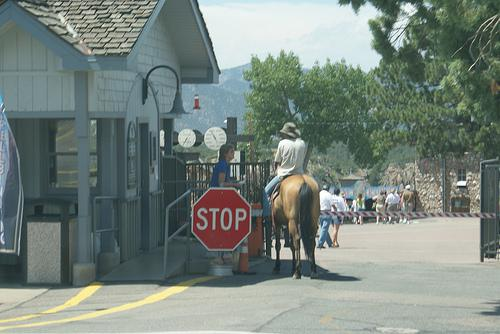Question: who is on a horse?
Choices:
A. A woman.
B. A man.
C. A child.
D. A person.
Answer with the letter. Answer: D Question: where are yellow lines?
Choices:
A. On the ground.
B. On the car.
C. On the bench.
D. On the window.
Answer with the letter. Answer: A Question: what is gray?
Choices:
A. Sky.
B. Ground.
C. Cat.
D. Man's hair.
Answer with the letter. Answer: B Question: what is brown?
Choices:
A. Horse.
B. Deer.
C. Dog.
D. Rabbit.
Answer with the letter. Answer: A Question: what is blue?
Choices:
A. Flowers.
B. Kite.
C. Sky.
D. Balloon.
Answer with the letter. Answer: C 